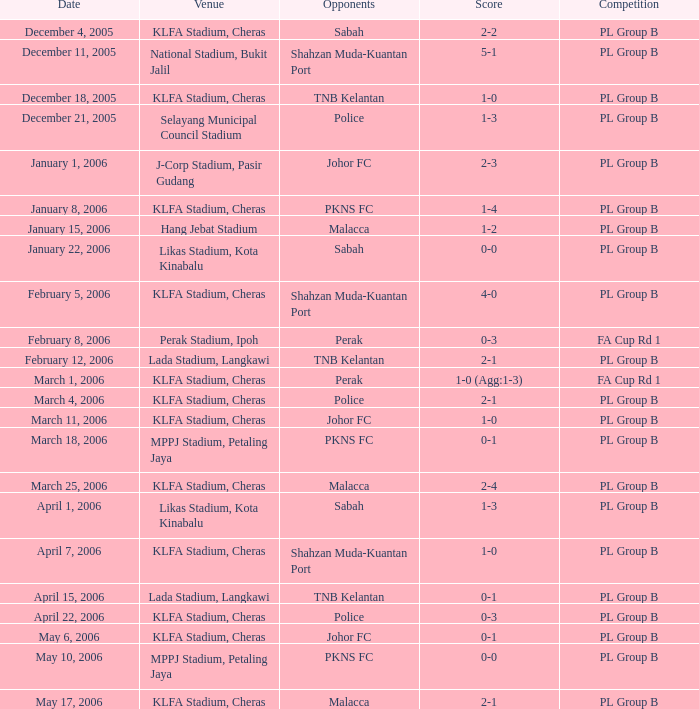Which Score has Opponents of pkns fc, and a Date of january 8, 2006? 1-4. 